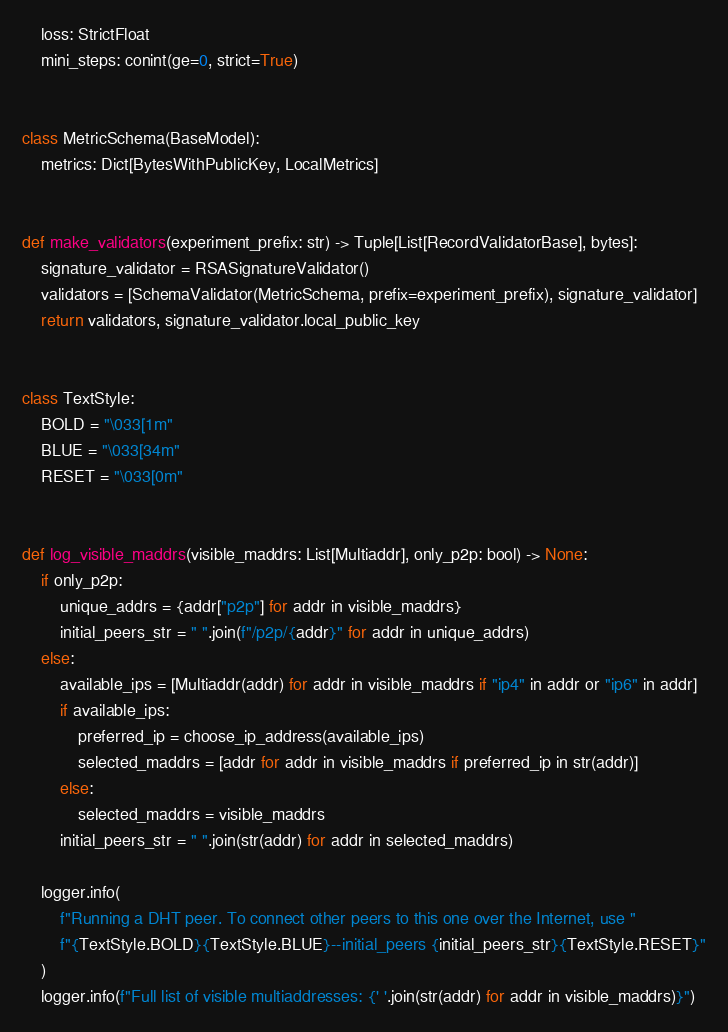<code> <loc_0><loc_0><loc_500><loc_500><_Python_>    loss: StrictFloat
    mini_steps: conint(ge=0, strict=True)


class MetricSchema(BaseModel):
    metrics: Dict[BytesWithPublicKey, LocalMetrics]


def make_validators(experiment_prefix: str) -> Tuple[List[RecordValidatorBase], bytes]:
    signature_validator = RSASignatureValidator()
    validators = [SchemaValidator(MetricSchema, prefix=experiment_prefix), signature_validator]
    return validators, signature_validator.local_public_key


class TextStyle:
    BOLD = "\033[1m"
    BLUE = "\033[34m"
    RESET = "\033[0m"


def log_visible_maddrs(visible_maddrs: List[Multiaddr], only_p2p: bool) -> None:
    if only_p2p:
        unique_addrs = {addr["p2p"] for addr in visible_maddrs}
        initial_peers_str = " ".join(f"/p2p/{addr}" for addr in unique_addrs)
    else:
        available_ips = [Multiaddr(addr) for addr in visible_maddrs if "ip4" in addr or "ip6" in addr]
        if available_ips:
            preferred_ip = choose_ip_address(available_ips)
            selected_maddrs = [addr for addr in visible_maddrs if preferred_ip in str(addr)]
        else:
            selected_maddrs = visible_maddrs
        initial_peers_str = " ".join(str(addr) for addr in selected_maddrs)

    logger.info(
        f"Running a DHT peer. To connect other peers to this one over the Internet, use "
        f"{TextStyle.BOLD}{TextStyle.BLUE}--initial_peers {initial_peers_str}{TextStyle.RESET}"
    )
    logger.info(f"Full list of visible multiaddresses: {' '.join(str(addr) for addr in visible_maddrs)}")
</code> 